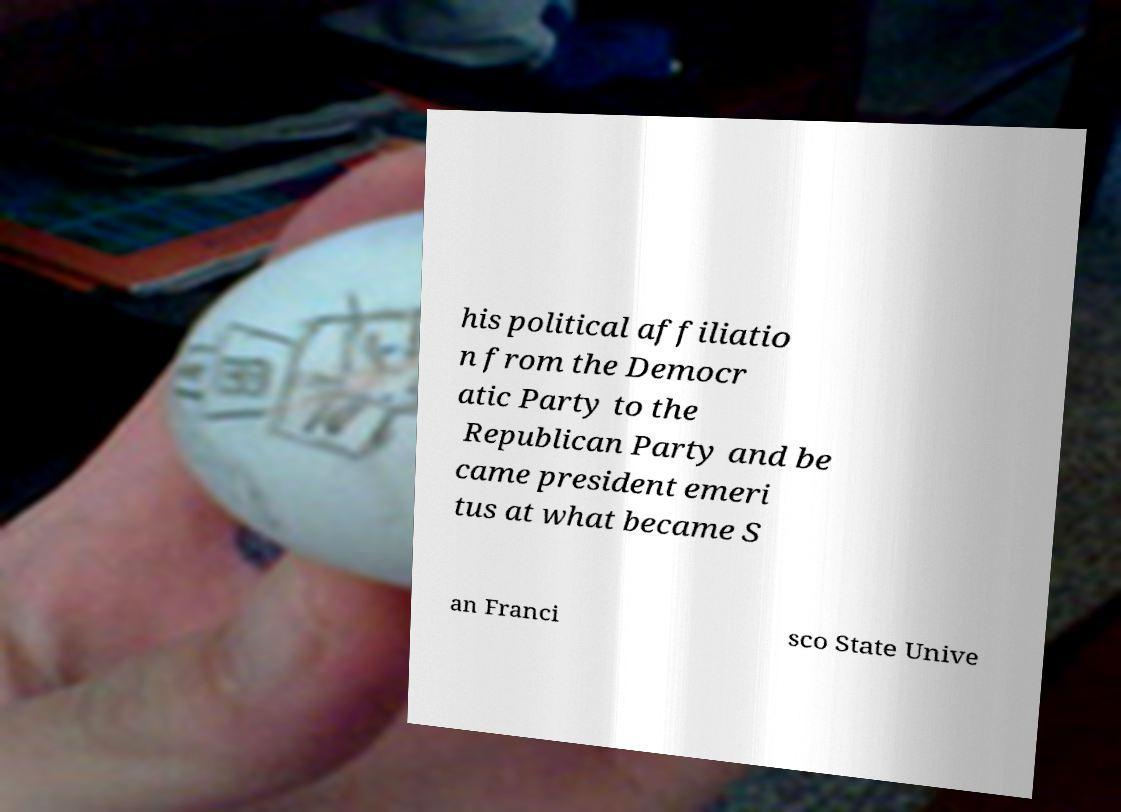Could you extract and type out the text from this image? his political affiliatio n from the Democr atic Party to the Republican Party and be came president emeri tus at what became S an Franci sco State Unive 